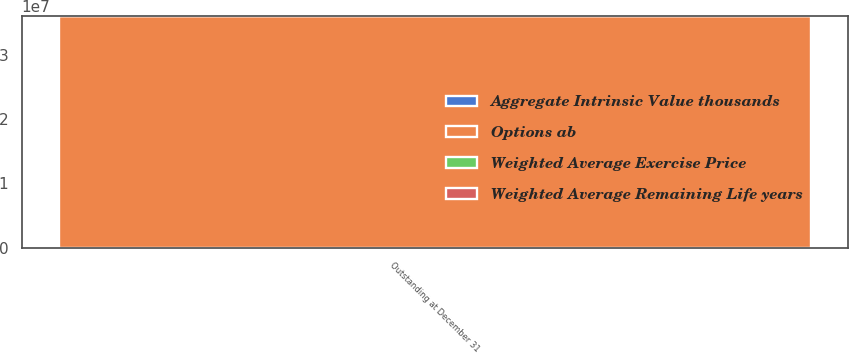<chart> <loc_0><loc_0><loc_500><loc_500><stacked_bar_chart><ecel><fcel>Outstanding at December 31<nl><fcel>Options ab<fcel>3.59827e+07<nl><fcel>Weighted Average Remaining Life years<fcel>39.52<nl><fcel>Weighted Average Exercise Price<fcel>5.08<nl><fcel>Aggregate Intrinsic Value thousands<fcel>1422<nl></chart> 